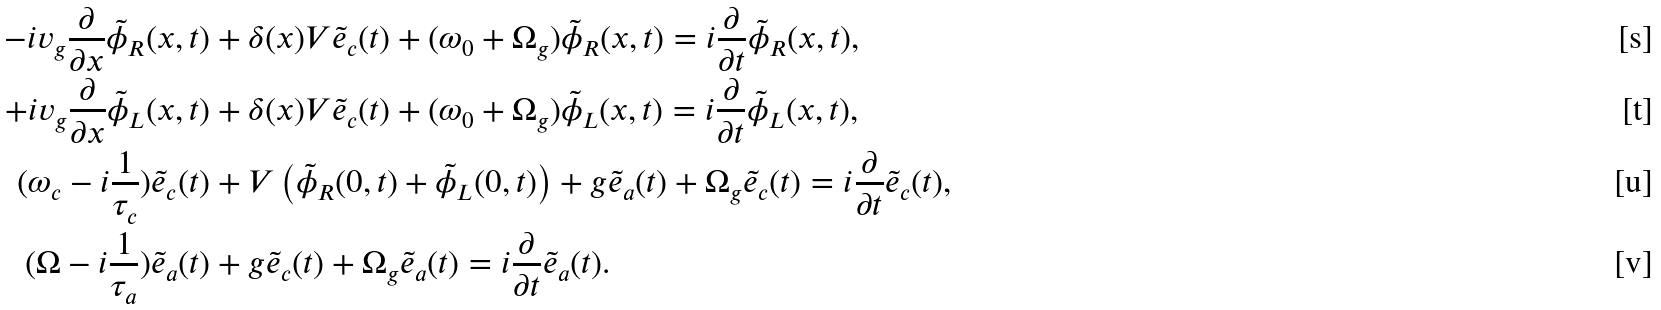<formula> <loc_0><loc_0><loc_500><loc_500>- i v _ { g } \frac { \partial } { \partial x } \tilde { \phi } _ { R } ( x , t ) & + \delta ( x ) V \tilde { e } _ { c } ( t ) + ( \omega _ { 0 } + \Omega _ { g } ) \tilde { \phi } _ { R } ( x , t ) = i \frac { \partial } { \partial t } \tilde { \phi } _ { R } ( x , t ) , \\ + i v _ { g } \frac { \partial } { \partial x } \tilde { \phi } _ { L } ( x , t ) & + \delta ( x ) V \tilde { e } _ { c } ( t ) + ( \omega _ { 0 } + \Omega _ { g } ) \tilde { \phi } _ { L } ( x , t ) = i \frac { \partial } { \partial t } \tilde { \phi } _ { L } ( x , t ) , \\ ( \omega _ { c } - i \frac { 1 } { \tau _ { c } } ) \tilde { e } _ { c } ( t ) & + V \left ( \tilde { \phi } _ { R } ( 0 , t ) + \tilde { \phi } _ { L } ( 0 , t ) \right ) + g \tilde { e } _ { a } ( t ) + \Omega _ { g } \tilde { e } _ { c } ( t ) = i \frac { \partial } { \partial t } \tilde { e } _ { c } ( t ) , \\ ( \Omega - i \frac { 1 } { \tau _ { a } } ) \tilde { e } _ { a } ( t ) & + g \tilde { e } _ { c } ( t ) + \Omega _ { g } \tilde { e } _ { a } ( t ) = i \frac { \partial } { \partial t } \tilde { e } _ { a } ( t ) .</formula> 